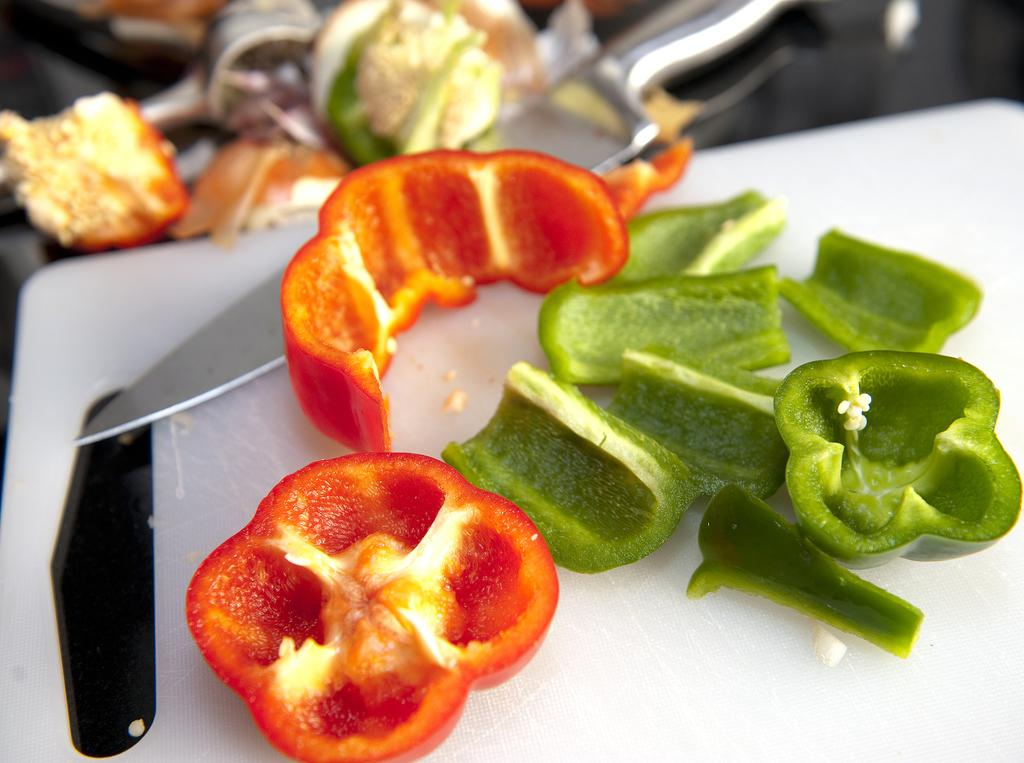What is visible on the chop board in the foreground of the image? There are capsicum pieces on a chop board in the foreground of the image. Can you describe the background of the image? The background images are not clear, so it is difficult to provide a detailed description. What type of boot is being ordered in the image? There is no boot or order present in the image; it features capsicum pieces on a chop board in the foreground and an unclear background. 